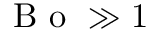<formula> <loc_0><loc_0><loc_500><loc_500>B o \gg 1</formula> 